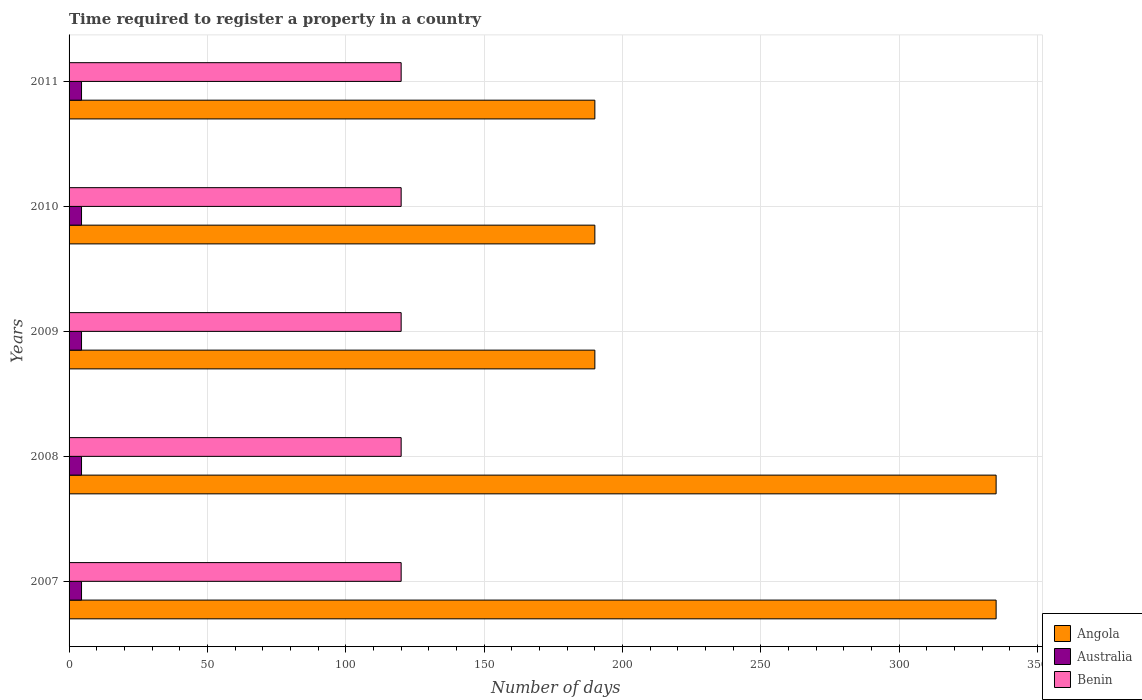How many different coloured bars are there?
Your answer should be very brief. 3. Are the number of bars on each tick of the Y-axis equal?
Give a very brief answer. Yes. In how many cases, is the number of bars for a given year not equal to the number of legend labels?
Offer a terse response. 0. What is the number of days required to register a property in Angola in 2011?
Keep it short and to the point. 190. Across all years, what is the maximum number of days required to register a property in Australia?
Offer a very short reply. 4.5. Across all years, what is the minimum number of days required to register a property in Benin?
Ensure brevity in your answer.  120. In which year was the number of days required to register a property in Australia maximum?
Give a very brief answer. 2007. In which year was the number of days required to register a property in Australia minimum?
Make the answer very short. 2007. What is the total number of days required to register a property in Australia in the graph?
Your response must be concise. 22.5. What is the difference between the number of days required to register a property in Angola in 2011 and the number of days required to register a property in Benin in 2008?
Offer a terse response. 70. What is the average number of days required to register a property in Australia per year?
Provide a short and direct response. 4.5. In the year 2011, what is the difference between the number of days required to register a property in Angola and number of days required to register a property in Benin?
Give a very brief answer. 70. In how many years, is the number of days required to register a property in Angola greater than 110 days?
Make the answer very short. 5. What is the ratio of the number of days required to register a property in Benin in 2009 to that in 2011?
Provide a short and direct response. 1. Is the number of days required to register a property in Australia in 2008 less than that in 2011?
Your answer should be compact. No. Is the difference between the number of days required to register a property in Angola in 2008 and 2011 greater than the difference between the number of days required to register a property in Benin in 2008 and 2011?
Ensure brevity in your answer.  Yes. What is the difference between the highest and the second highest number of days required to register a property in Benin?
Your answer should be very brief. 0. What does the 3rd bar from the top in 2008 represents?
Keep it short and to the point. Angola. What does the 1st bar from the bottom in 2008 represents?
Your answer should be compact. Angola. Are all the bars in the graph horizontal?
Offer a very short reply. Yes. How many years are there in the graph?
Offer a terse response. 5. What is the difference between two consecutive major ticks on the X-axis?
Your response must be concise. 50. Are the values on the major ticks of X-axis written in scientific E-notation?
Make the answer very short. No. How many legend labels are there?
Your response must be concise. 3. How are the legend labels stacked?
Provide a short and direct response. Vertical. What is the title of the graph?
Offer a terse response. Time required to register a property in a country. Does "New Caledonia" appear as one of the legend labels in the graph?
Your answer should be compact. No. What is the label or title of the X-axis?
Ensure brevity in your answer.  Number of days. What is the Number of days of Angola in 2007?
Give a very brief answer. 335. What is the Number of days in Australia in 2007?
Keep it short and to the point. 4.5. What is the Number of days of Benin in 2007?
Offer a terse response. 120. What is the Number of days of Angola in 2008?
Provide a short and direct response. 335. What is the Number of days of Benin in 2008?
Provide a short and direct response. 120. What is the Number of days of Angola in 2009?
Provide a succinct answer. 190. What is the Number of days in Benin in 2009?
Your response must be concise. 120. What is the Number of days in Angola in 2010?
Keep it short and to the point. 190. What is the Number of days of Australia in 2010?
Offer a terse response. 4.5. What is the Number of days of Benin in 2010?
Provide a succinct answer. 120. What is the Number of days in Angola in 2011?
Your answer should be very brief. 190. What is the Number of days of Australia in 2011?
Offer a very short reply. 4.5. What is the Number of days in Benin in 2011?
Offer a very short reply. 120. Across all years, what is the maximum Number of days in Angola?
Your answer should be compact. 335. Across all years, what is the maximum Number of days in Australia?
Your answer should be very brief. 4.5. Across all years, what is the maximum Number of days of Benin?
Your answer should be very brief. 120. Across all years, what is the minimum Number of days of Angola?
Offer a very short reply. 190. Across all years, what is the minimum Number of days in Australia?
Your response must be concise. 4.5. Across all years, what is the minimum Number of days of Benin?
Provide a succinct answer. 120. What is the total Number of days of Angola in the graph?
Give a very brief answer. 1240. What is the total Number of days of Benin in the graph?
Give a very brief answer. 600. What is the difference between the Number of days in Angola in 2007 and that in 2008?
Make the answer very short. 0. What is the difference between the Number of days in Benin in 2007 and that in 2008?
Ensure brevity in your answer.  0. What is the difference between the Number of days of Angola in 2007 and that in 2009?
Offer a terse response. 145. What is the difference between the Number of days in Benin in 2007 and that in 2009?
Your response must be concise. 0. What is the difference between the Number of days in Angola in 2007 and that in 2010?
Your answer should be very brief. 145. What is the difference between the Number of days in Benin in 2007 and that in 2010?
Your response must be concise. 0. What is the difference between the Number of days of Angola in 2007 and that in 2011?
Your answer should be very brief. 145. What is the difference between the Number of days of Benin in 2007 and that in 2011?
Offer a terse response. 0. What is the difference between the Number of days of Angola in 2008 and that in 2009?
Ensure brevity in your answer.  145. What is the difference between the Number of days of Australia in 2008 and that in 2009?
Provide a succinct answer. 0. What is the difference between the Number of days in Angola in 2008 and that in 2010?
Offer a terse response. 145. What is the difference between the Number of days in Benin in 2008 and that in 2010?
Your answer should be very brief. 0. What is the difference between the Number of days of Angola in 2008 and that in 2011?
Your answer should be compact. 145. What is the difference between the Number of days in Angola in 2009 and that in 2010?
Offer a very short reply. 0. What is the difference between the Number of days of Australia in 2009 and that in 2010?
Your answer should be very brief. 0. What is the difference between the Number of days in Benin in 2009 and that in 2010?
Give a very brief answer. 0. What is the difference between the Number of days in Angola in 2009 and that in 2011?
Make the answer very short. 0. What is the difference between the Number of days of Australia in 2009 and that in 2011?
Ensure brevity in your answer.  0. What is the difference between the Number of days of Australia in 2010 and that in 2011?
Provide a succinct answer. 0. What is the difference between the Number of days in Benin in 2010 and that in 2011?
Provide a short and direct response. 0. What is the difference between the Number of days of Angola in 2007 and the Number of days of Australia in 2008?
Provide a short and direct response. 330.5. What is the difference between the Number of days of Angola in 2007 and the Number of days of Benin in 2008?
Offer a terse response. 215. What is the difference between the Number of days in Australia in 2007 and the Number of days in Benin in 2008?
Your answer should be very brief. -115.5. What is the difference between the Number of days of Angola in 2007 and the Number of days of Australia in 2009?
Give a very brief answer. 330.5. What is the difference between the Number of days of Angola in 2007 and the Number of days of Benin in 2009?
Keep it short and to the point. 215. What is the difference between the Number of days in Australia in 2007 and the Number of days in Benin in 2009?
Provide a short and direct response. -115.5. What is the difference between the Number of days in Angola in 2007 and the Number of days in Australia in 2010?
Your answer should be compact. 330.5. What is the difference between the Number of days in Angola in 2007 and the Number of days in Benin in 2010?
Your response must be concise. 215. What is the difference between the Number of days in Australia in 2007 and the Number of days in Benin in 2010?
Offer a very short reply. -115.5. What is the difference between the Number of days in Angola in 2007 and the Number of days in Australia in 2011?
Keep it short and to the point. 330.5. What is the difference between the Number of days of Angola in 2007 and the Number of days of Benin in 2011?
Your answer should be compact. 215. What is the difference between the Number of days of Australia in 2007 and the Number of days of Benin in 2011?
Your answer should be compact. -115.5. What is the difference between the Number of days in Angola in 2008 and the Number of days in Australia in 2009?
Ensure brevity in your answer.  330.5. What is the difference between the Number of days of Angola in 2008 and the Number of days of Benin in 2009?
Your answer should be compact. 215. What is the difference between the Number of days of Australia in 2008 and the Number of days of Benin in 2009?
Your response must be concise. -115.5. What is the difference between the Number of days of Angola in 2008 and the Number of days of Australia in 2010?
Ensure brevity in your answer.  330.5. What is the difference between the Number of days of Angola in 2008 and the Number of days of Benin in 2010?
Keep it short and to the point. 215. What is the difference between the Number of days of Australia in 2008 and the Number of days of Benin in 2010?
Provide a short and direct response. -115.5. What is the difference between the Number of days of Angola in 2008 and the Number of days of Australia in 2011?
Your answer should be compact. 330.5. What is the difference between the Number of days in Angola in 2008 and the Number of days in Benin in 2011?
Offer a terse response. 215. What is the difference between the Number of days of Australia in 2008 and the Number of days of Benin in 2011?
Your answer should be very brief. -115.5. What is the difference between the Number of days in Angola in 2009 and the Number of days in Australia in 2010?
Your answer should be compact. 185.5. What is the difference between the Number of days in Australia in 2009 and the Number of days in Benin in 2010?
Offer a very short reply. -115.5. What is the difference between the Number of days of Angola in 2009 and the Number of days of Australia in 2011?
Ensure brevity in your answer.  185.5. What is the difference between the Number of days in Australia in 2009 and the Number of days in Benin in 2011?
Offer a very short reply. -115.5. What is the difference between the Number of days in Angola in 2010 and the Number of days in Australia in 2011?
Your response must be concise. 185.5. What is the difference between the Number of days in Australia in 2010 and the Number of days in Benin in 2011?
Your answer should be compact. -115.5. What is the average Number of days in Angola per year?
Give a very brief answer. 248. What is the average Number of days of Australia per year?
Make the answer very short. 4.5. What is the average Number of days in Benin per year?
Offer a terse response. 120. In the year 2007, what is the difference between the Number of days of Angola and Number of days of Australia?
Provide a short and direct response. 330.5. In the year 2007, what is the difference between the Number of days of Angola and Number of days of Benin?
Your answer should be compact. 215. In the year 2007, what is the difference between the Number of days of Australia and Number of days of Benin?
Provide a succinct answer. -115.5. In the year 2008, what is the difference between the Number of days in Angola and Number of days in Australia?
Provide a short and direct response. 330.5. In the year 2008, what is the difference between the Number of days in Angola and Number of days in Benin?
Give a very brief answer. 215. In the year 2008, what is the difference between the Number of days of Australia and Number of days of Benin?
Keep it short and to the point. -115.5. In the year 2009, what is the difference between the Number of days in Angola and Number of days in Australia?
Keep it short and to the point. 185.5. In the year 2009, what is the difference between the Number of days in Australia and Number of days in Benin?
Your answer should be compact. -115.5. In the year 2010, what is the difference between the Number of days in Angola and Number of days in Australia?
Ensure brevity in your answer.  185.5. In the year 2010, what is the difference between the Number of days in Australia and Number of days in Benin?
Your answer should be compact. -115.5. In the year 2011, what is the difference between the Number of days in Angola and Number of days in Australia?
Provide a succinct answer. 185.5. In the year 2011, what is the difference between the Number of days of Angola and Number of days of Benin?
Make the answer very short. 70. In the year 2011, what is the difference between the Number of days of Australia and Number of days of Benin?
Offer a very short reply. -115.5. What is the ratio of the Number of days of Angola in 2007 to that in 2008?
Your response must be concise. 1. What is the ratio of the Number of days of Angola in 2007 to that in 2009?
Ensure brevity in your answer.  1.76. What is the ratio of the Number of days in Benin in 2007 to that in 2009?
Keep it short and to the point. 1. What is the ratio of the Number of days of Angola in 2007 to that in 2010?
Offer a very short reply. 1.76. What is the ratio of the Number of days in Australia in 2007 to that in 2010?
Ensure brevity in your answer.  1. What is the ratio of the Number of days of Angola in 2007 to that in 2011?
Give a very brief answer. 1.76. What is the ratio of the Number of days of Australia in 2007 to that in 2011?
Your answer should be compact. 1. What is the ratio of the Number of days of Angola in 2008 to that in 2009?
Your answer should be very brief. 1.76. What is the ratio of the Number of days in Benin in 2008 to that in 2009?
Your response must be concise. 1. What is the ratio of the Number of days in Angola in 2008 to that in 2010?
Give a very brief answer. 1.76. What is the ratio of the Number of days in Australia in 2008 to that in 2010?
Ensure brevity in your answer.  1. What is the ratio of the Number of days of Angola in 2008 to that in 2011?
Your answer should be very brief. 1.76. What is the ratio of the Number of days in Benin in 2008 to that in 2011?
Offer a very short reply. 1. What is the ratio of the Number of days in Angola in 2009 to that in 2010?
Provide a short and direct response. 1. What is the ratio of the Number of days of Australia in 2009 to that in 2011?
Give a very brief answer. 1. What is the ratio of the Number of days in Benin in 2009 to that in 2011?
Keep it short and to the point. 1. What is the ratio of the Number of days in Angola in 2010 to that in 2011?
Give a very brief answer. 1. What is the ratio of the Number of days in Benin in 2010 to that in 2011?
Your answer should be compact. 1. What is the difference between the highest and the second highest Number of days of Angola?
Provide a short and direct response. 0. What is the difference between the highest and the second highest Number of days in Australia?
Provide a succinct answer. 0. What is the difference between the highest and the second highest Number of days in Benin?
Offer a terse response. 0. What is the difference between the highest and the lowest Number of days of Angola?
Provide a short and direct response. 145. 